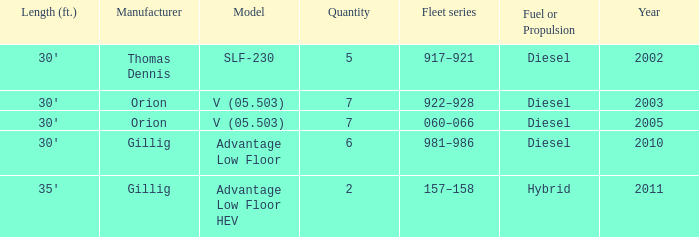Name the fleet series with a quantity of 5 917–921. Help me parse the entirety of this table. {'header': ['Length (ft.)', 'Manufacturer', 'Model', 'Quantity', 'Fleet series', 'Fuel or Propulsion', 'Year'], 'rows': [["30'", 'Thomas Dennis', 'SLF-230', '5', '917–921', 'Diesel', '2002'], ["30'", 'Orion', 'V (05.503)', '7', '922–928', 'Diesel', '2003'], ["30'", 'Orion', 'V (05.503)', '7', '060–066', 'Diesel', '2005'], ["30'", 'Gillig', 'Advantage Low Floor', '6', '981–986', 'Diesel', '2010'], ["35'", 'Gillig', 'Advantage Low Floor HEV', '2', '157–158', 'Hybrid', '2011']]} 